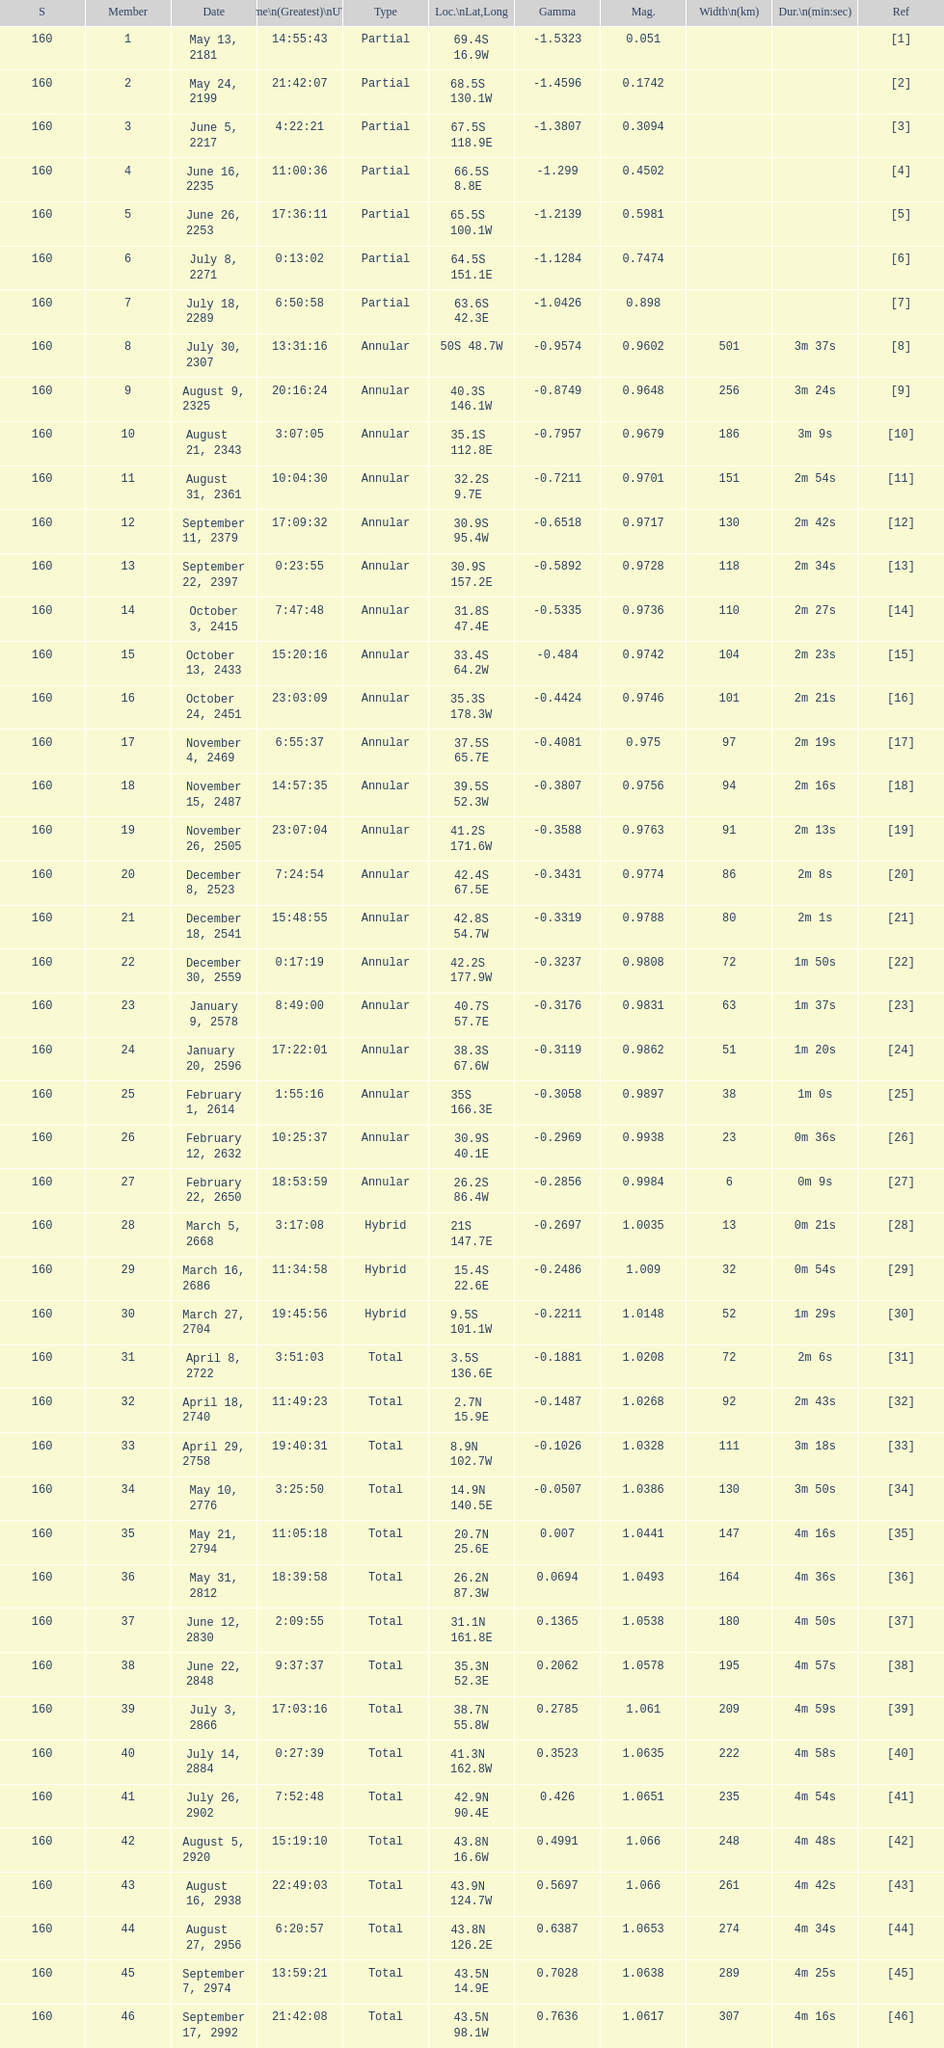What is the difference in magnitude between the may 13, 2181 solar saros and the may 24, 2199 solar saros? 0.1232. 